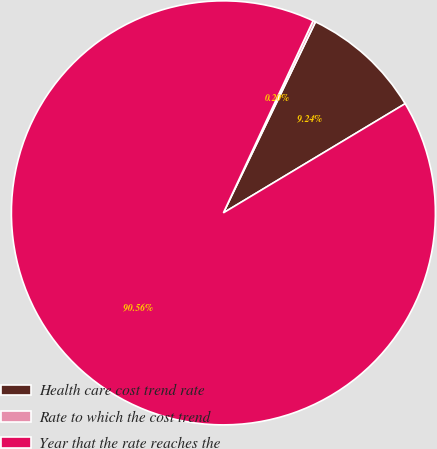<chart> <loc_0><loc_0><loc_500><loc_500><pie_chart><fcel>Health care cost trend rate<fcel>Rate to which the cost trend<fcel>Year that the rate reaches the<nl><fcel>9.24%<fcel>0.2%<fcel>90.57%<nl></chart> 